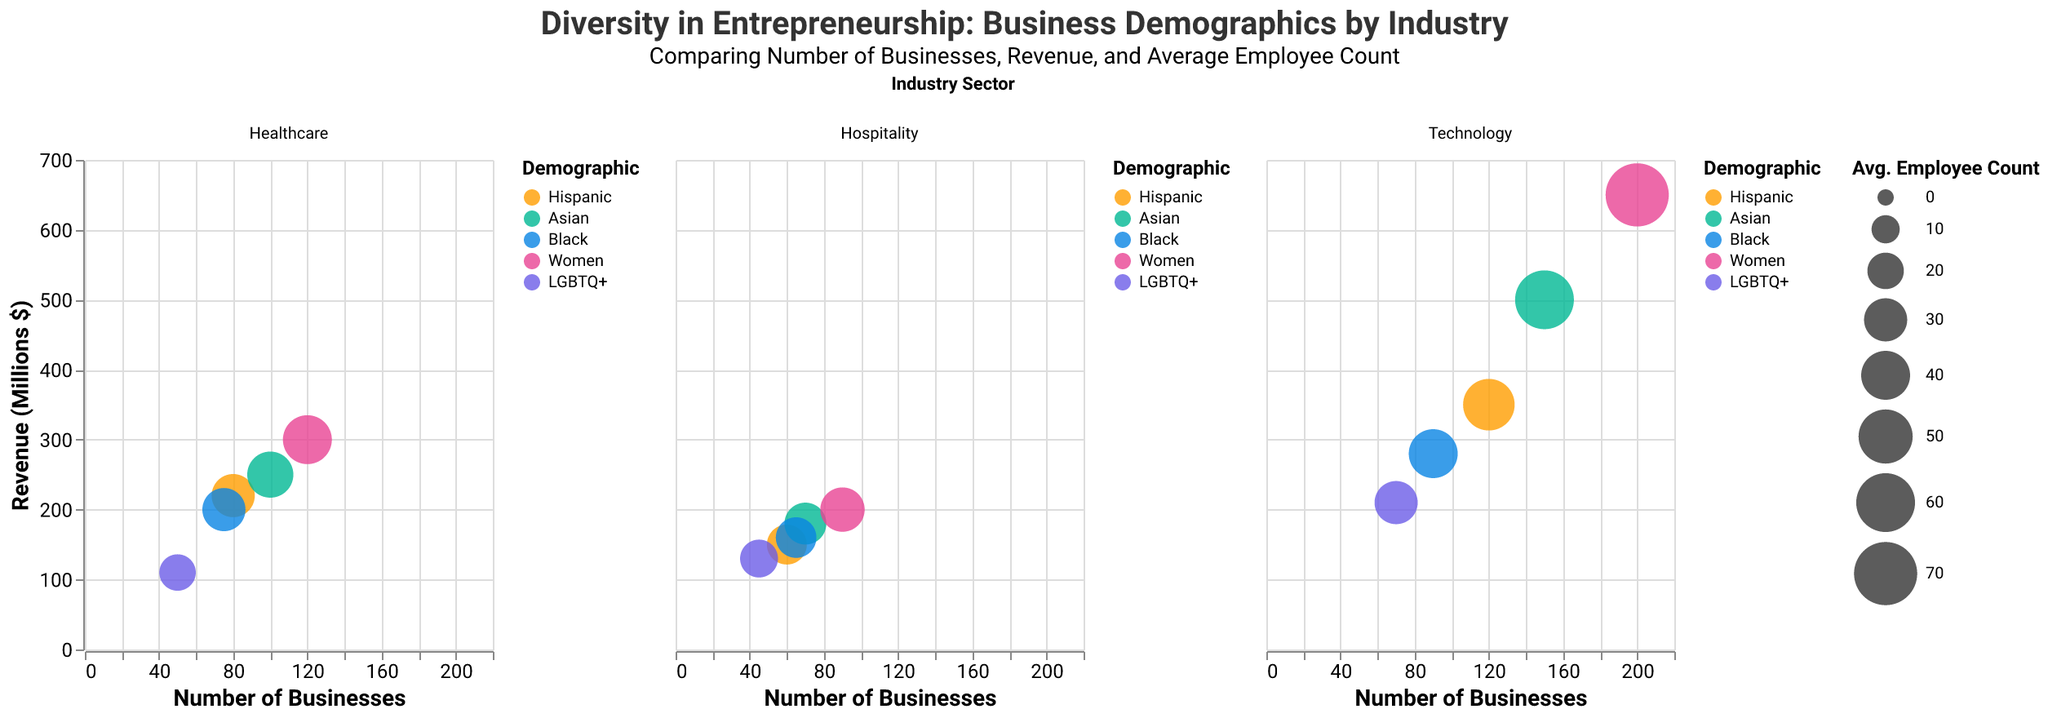What is the title of the figure? The title of the figure is displayed at the top and provides a summary of the chart's content. The title is "Diversity in Entrepreneurship: Business Demographics by Industry."
Answer: Diversity in Entrepreneurship: Business Demographics by Industry Which demographic has the highest number of businesses in the Technology sector? To identify this, look at the Technology sector and locate the bubble representing the highest number on the x-axis. The largest number of businesses in the Technology sector is represented by a bubble for the "Women" demographic.
Answer: Women Which industry shows the highest revenue among Hispanic business owners? Look at the bubbles within each industry sector's subplot for the Hispanic demographic. The bubble positioned at the highest point on the y-axis represents the highest revenue. For Hispanic business owners, the highest revenue is in the Technology sector.
Answer: Technology What is the average employee count for Asian business owners in the Healthcare sector? Examine the bubble size in the Healthcare sector for the Asian demographic. The bubble size represents the average employee count. According to the provided data, it is 35.
Answer: 35 Compare the revenue of LGBTQ+ businesses in Technology and Hospitality sectors. Which one is higher? To compare, look at the y-axis positions within the Technology and Hospitality sector subplots for the LGBTQ+ demographic. The bubble for Technology is higher on the y-axis (210 million) than the one for Hospitality (130 million).
Answer: Technology How many businesses are owned by Black entrepreneurs in the Hospitality sector? Check the number on the x-axis within the Hospitality subplot for the Black demographic. The corresponding number of businesses is 65.
Answer: 65 Which demographic has the most diversified industry presence in terms of the number of sectors they are involved in? Assess the subplots and count the distinct industry sectors in which each demographic appears. The "Women" demographic is involved in all three sectors (Technology, Healthcare, Hospitality).
Answer: Women What is the combined revenue of Healthcare businesses owned by Hispanic and Asian entrepreneurs? Calculate the sum of the revenue for Hispanic (220 million) and Asian (250 million) business owners in Healthcare. The total is 220 + 250 = 470 million.
Answer: 470 million Which demographic has the lowest average employee count in any industry, and in which industry is this? Look at the smallest bubble sizes across all sectors for each demographic. The smallest bubble, indicating the lowest average employee count, is within the Healthcare industry for the LGBTQ+ demographic, with an average employee count of 20.
Answer: LGBTQ+ in Healthcare Are there more businesses owned by Asian entrepreneurs in Hospitality or Hispanic entrepreneurs in Technology? Compare the number on the x-axis for Asian in Hospitality (70) to Hispanic in Technology (120). The Hispanic entrepreneurs in Technology own more businesses.
Answer: Hispanic entrepreneurs in Technology 